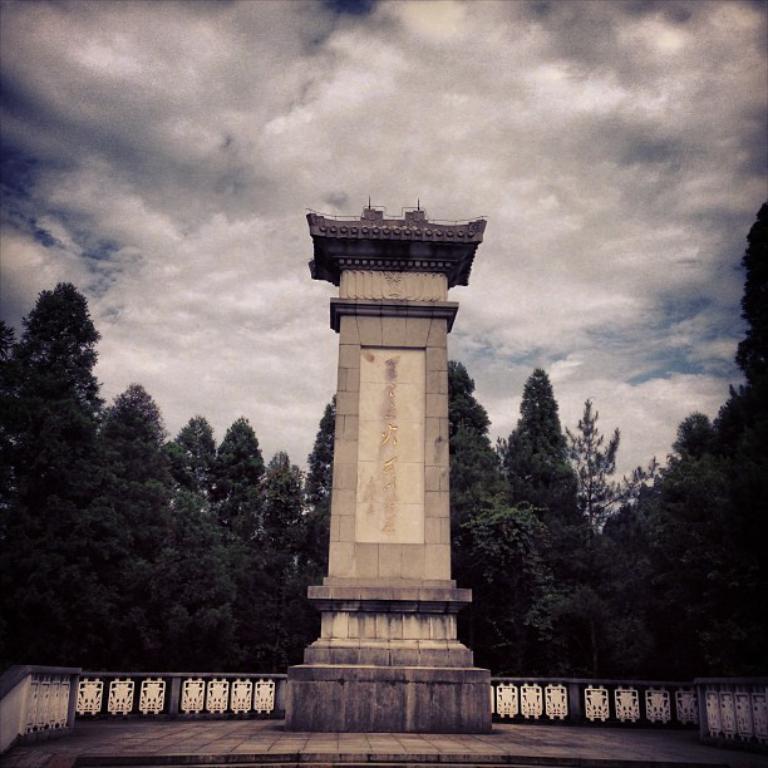How would you summarize this image in a sentence or two? In this image in the center there is a tower and in the background there are trees and in the center there is a fence and the sky is cloudy. 